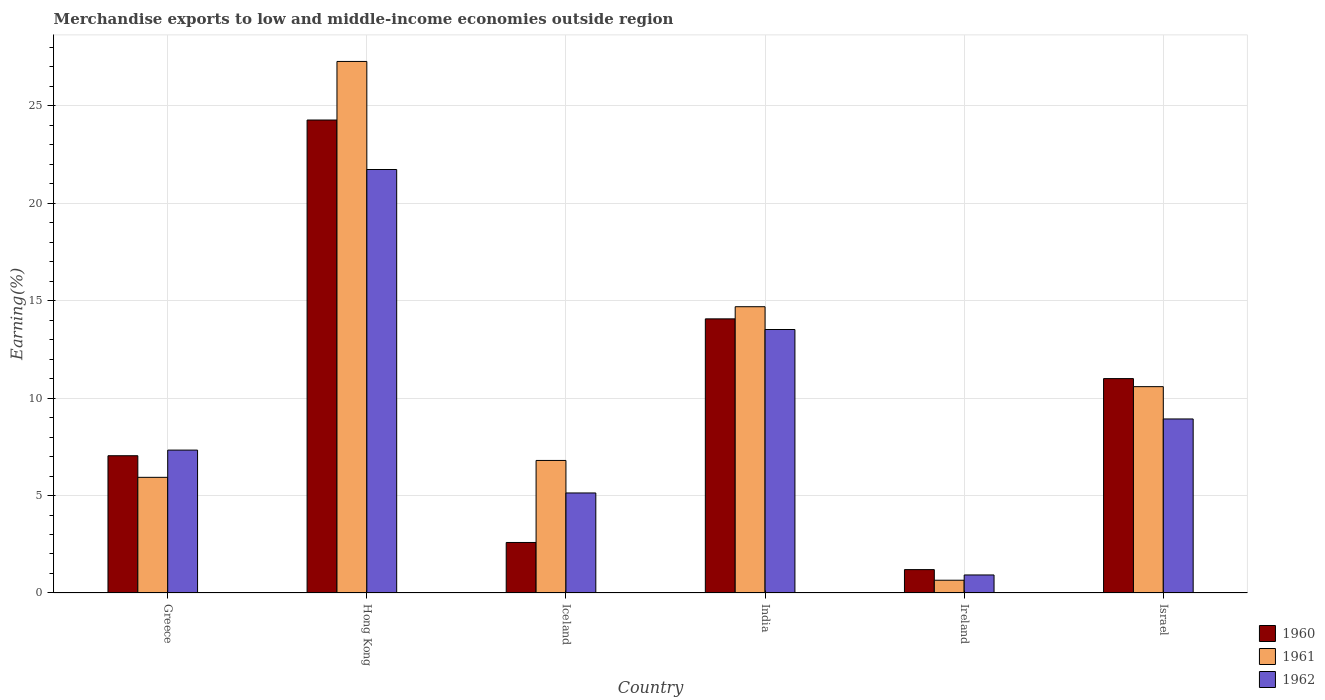How many different coloured bars are there?
Keep it short and to the point. 3. How many groups of bars are there?
Make the answer very short. 6. How many bars are there on the 4th tick from the left?
Offer a terse response. 3. How many bars are there on the 6th tick from the right?
Your response must be concise. 3. What is the percentage of amount earned from merchandise exports in 1962 in Hong Kong?
Keep it short and to the point. 21.72. Across all countries, what is the maximum percentage of amount earned from merchandise exports in 1962?
Make the answer very short. 21.72. Across all countries, what is the minimum percentage of amount earned from merchandise exports in 1960?
Give a very brief answer. 1.2. In which country was the percentage of amount earned from merchandise exports in 1960 maximum?
Offer a terse response. Hong Kong. In which country was the percentage of amount earned from merchandise exports in 1962 minimum?
Keep it short and to the point. Ireland. What is the total percentage of amount earned from merchandise exports in 1962 in the graph?
Provide a short and direct response. 57.55. What is the difference between the percentage of amount earned from merchandise exports in 1960 in Hong Kong and that in Ireland?
Keep it short and to the point. 23.06. What is the difference between the percentage of amount earned from merchandise exports in 1961 in India and the percentage of amount earned from merchandise exports in 1960 in Hong Kong?
Provide a short and direct response. -9.58. What is the average percentage of amount earned from merchandise exports in 1961 per country?
Make the answer very short. 10.99. What is the difference between the percentage of amount earned from merchandise exports of/in 1961 and percentage of amount earned from merchandise exports of/in 1962 in India?
Your answer should be compact. 1.17. What is the ratio of the percentage of amount earned from merchandise exports in 1962 in Greece to that in India?
Make the answer very short. 0.54. Is the difference between the percentage of amount earned from merchandise exports in 1961 in Ireland and Israel greater than the difference between the percentage of amount earned from merchandise exports in 1962 in Ireland and Israel?
Your answer should be compact. No. What is the difference between the highest and the second highest percentage of amount earned from merchandise exports in 1961?
Your answer should be compact. -16.68. What is the difference between the highest and the lowest percentage of amount earned from merchandise exports in 1961?
Your response must be concise. 26.61. What does the 2nd bar from the right in Greece represents?
Give a very brief answer. 1961. Are the values on the major ticks of Y-axis written in scientific E-notation?
Make the answer very short. No. Does the graph contain any zero values?
Make the answer very short. No. Does the graph contain grids?
Offer a terse response. Yes. How are the legend labels stacked?
Ensure brevity in your answer.  Vertical. What is the title of the graph?
Offer a terse response. Merchandise exports to low and middle-income economies outside region. Does "1963" appear as one of the legend labels in the graph?
Provide a short and direct response. No. What is the label or title of the X-axis?
Your response must be concise. Country. What is the label or title of the Y-axis?
Offer a terse response. Earning(%). What is the Earning(%) of 1960 in Greece?
Give a very brief answer. 7.04. What is the Earning(%) of 1961 in Greece?
Offer a terse response. 5.93. What is the Earning(%) of 1962 in Greece?
Keep it short and to the point. 7.33. What is the Earning(%) of 1960 in Hong Kong?
Give a very brief answer. 24.26. What is the Earning(%) of 1961 in Hong Kong?
Offer a terse response. 27.27. What is the Earning(%) of 1962 in Hong Kong?
Your answer should be very brief. 21.72. What is the Earning(%) of 1960 in Iceland?
Make the answer very short. 2.59. What is the Earning(%) in 1961 in Iceland?
Provide a short and direct response. 6.8. What is the Earning(%) of 1962 in Iceland?
Provide a short and direct response. 5.13. What is the Earning(%) in 1960 in India?
Offer a terse response. 14.06. What is the Earning(%) in 1961 in India?
Keep it short and to the point. 14.68. What is the Earning(%) in 1962 in India?
Offer a very short reply. 13.52. What is the Earning(%) in 1960 in Ireland?
Your answer should be compact. 1.2. What is the Earning(%) in 1961 in Ireland?
Provide a short and direct response. 0.65. What is the Earning(%) of 1962 in Ireland?
Provide a short and direct response. 0.92. What is the Earning(%) in 1960 in Israel?
Your response must be concise. 11. What is the Earning(%) in 1961 in Israel?
Your response must be concise. 10.58. What is the Earning(%) of 1962 in Israel?
Your response must be concise. 8.93. Across all countries, what is the maximum Earning(%) in 1960?
Your response must be concise. 24.26. Across all countries, what is the maximum Earning(%) of 1961?
Your response must be concise. 27.27. Across all countries, what is the maximum Earning(%) of 1962?
Give a very brief answer. 21.72. Across all countries, what is the minimum Earning(%) in 1960?
Provide a succinct answer. 1.2. Across all countries, what is the minimum Earning(%) of 1961?
Ensure brevity in your answer.  0.65. Across all countries, what is the minimum Earning(%) in 1962?
Your answer should be very brief. 0.92. What is the total Earning(%) in 1960 in the graph?
Your answer should be compact. 60.15. What is the total Earning(%) in 1961 in the graph?
Provide a short and direct response. 65.92. What is the total Earning(%) of 1962 in the graph?
Make the answer very short. 57.55. What is the difference between the Earning(%) of 1960 in Greece and that in Hong Kong?
Keep it short and to the point. -17.22. What is the difference between the Earning(%) in 1961 in Greece and that in Hong Kong?
Your answer should be compact. -21.33. What is the difference between the Earning(%) of 1962 in Greece and that in Hong Kong?
Provide a short and direct response. -14.39. What is the difference between the Earning(%) of 1960 in Greece and that in Iceland?
Your answer should be very brief. 4.45. What is the difference between the Earning(%) of 1961 in Greece and that in Iceland?
Offer a terse response. -0.87. What is the difference between the Earning(%) in 1962 in Greece and that in Iceland?
Your answer should be very brief. 2.2. What is the difference between the Earning(%) in 1960 in Greece and that in India?
Ensure brevity in your answer.  -7.02. What is the difference between the Earning(%) in 1961 in Greece and that in India?
Provide a succinct answer. -8.75. What is the difference between the Earning(%) in 1962 in Greece and that in India?
Offer a very short reply. -6.19. What is the difference between the Earning(%) in 1960 in Greece and that in Ireland?
Make the answer very short. 5.84. What is the difference between the Earning(%) in 1961 in Greece and that in Ireland?
Offer a terse response. 5.28. What is the difference between the Earning(%) in 1962 in Greece and that in Ireland?
Your response must be concise. 6.41. What is the difference between the Earning(%) in 1960 in Greece and that in Israel?
Keep it short and to the point. -3.96. What is the difference between the Earning(%) of 1961 in Greece and that in Israel?
Give a very brief answer. -4.65. What is the difference between the Earning(%) in 1962 in Greece and that in Israel?
Your response must be concise. -1.6. What is the difference between the Earning(%) of 1960 in Hong Kong and that in Iceland?
Provide a succinct answer. 21.67. What is the difference between the Earning(%) in 1961 in Hong Kong and that in Iceland?
Give a very brief answer. 20.47. What is the difference between the Earning(%) in 1962 in Hong Kong and that in Iceland?
Give a very brief answer. 16.59. What is the difference between the Earning(%) in 1960 in Hong Kong and that in India?
Your response must be concise. 10.2. What is the difference between the Earning(%) of 1961 in Hong Kong and that in India?
Your answer should be compact. 12.58. What is the difference between the Earning(%) in 1962 in Hong Kong and that in India?
Keep it short and to the point. 8.21. What is the difference between the Earning(%) of 1960 in Hong Kong and that in Ireland?
Keep it short and to the point. 23.06. What is the difference between the Earning(%) of 1961 in Hong Kong and that in Ireland?
Keep it short and to the point. 26.61. What is the difference between the Earning(%) of 1962 in Hong Kong and that in Ireland?
Offer a terse response. 20.8. What is the difference between the Earning(%) of 1960 in Hong Kong and that in Israel?
Offer a very short reply. 13.26. What is the difference between the Earning(%) of 1961 in Hong Kong and that in Israel?
Ensure brevity in your answer.  16.68. What is the difference between the Earning(%) in 1962 in Hong Kong and that in Israel?
Ensure brevity in your answer.  12.8. What is the difference between the Earning(%) in 1960 in Iceland and that in India?
Provide a short and direct response. -11.47. What is the difference between the Earning(%) of 1961 in Iceland and that in India?
Provide a succinct answer. -7.89. What is the difference between the Earning(%) of 1962 in Iceland and that in India?
Give a very brief answer. -8.38. What is the difference between the Earning(%) in 1960 in Iceland and that in Ireland?
Offer a very short reply. 1.39. What is the difference between the Earning(%) of 1961 in Iceland and that in Ireland?
Your response must be concise. 6.14. What is the difference between the Earning(%) in 1962 in Iceland and that in Ireland?
Keep it short and to the point. 4.21. What is the difference between the Earning(%) in 1960 in Iceland and that in Israel?
Keep it short and to the point. -8.41. What is the difference between the Earning(%) of 1961 in Iceland and that in Israel?
Make the answer very short. -3.79. What is the difference between the Earning(%) of 1962 in Iceland and that in Israel?
Offer a terse response. -3.8. What is the difference between the Earning(%) of 1960 in India and that in Ireland?
Give a very brief answer. 12.86. What is the difference between the Earning(%) in 1961 in India and that in Ireland?
Provide a succinct answer. 14.03. What is the difference between the Earning(%) in 1962 in India and that in Ireland?
Ensure brevity in your answer.  12.59. What is the difference between the Earning(%) in 1960 in India and that in Israel?
Your answer should be very brief. 3.06. What is the difference between the Earning(%) of 1961 in India and that in Israel?
Give a very brief answer. 4.1. What is the difference between the Earning(%) of 1962 in India and that in Israel?
Ensure brevity in your answer.  4.59. What is the difference between the Earning(%) of 1960 in Ireland and that in Israel?
Your answer should be very brief. -9.8. What is the difference between the Earning(%) in 1961 in Ireland and that in Israel?
Your response must be concise. -9.93. What is the difference between the Earning(%) in 1962 in Ireland and that in Israel?
Your answer should be compact. -8. What is the difference between the Earning(%) of 1960 in Greece and the Earning(%) of 1961 in Hong Kong?
Keep it short and to the point. -20.22. What is the difference between the Earning(%) of 1960 in Greece and the Earning(%) of 1962 in Hong Kong?
Make the answer very short. -14.68. What is the difference between the Earning(%) in 1961 in Greece and the Earning(%) in 1962 in Hong Kong?
Make the answer very short. -15.79. What is the difference between the Earning(%) in 1960 in Greece and the Earning(%) in 1961 in Iceland?
Your answer should be compact. 0.24. What is the difference between the Earning(%) in 1960 in Greece and the Earning(%) in 1962 in Iceland?
Offer a very short reply. 1.91. What is the difference between the Earning(%) in 1961 in Greece and the Earning(%) in 1962 in Iceland?
Give a very brief answer. 0.8. What is the difference between the Earning(%) of 1960 in Greece and the Earning(%) of 1961 in India?
Give a very brief answer. -7.64. What is the difference between the Earning(%) of 1960 in Greece and the Earning(%) of 1962 in India?
Make the answer very short. -6.47. What is the difference between the Earning(%) in 1961 in Greece and the Earning(%) in 1962 in India?
Offer a terse response. -7.58. What is the difference between the Earning(%) in 1960 in Greece and the Earning(%) in 1961 in Ireland?
Ensure brevity in your answer.  6.39. What is the difference between the Earning(%) of 1960 in Greece and the Earning(%) of 1962 in Ireland?
Ensure brevity in your answer.  6.12. What is the difference between the Earning(%) in 1961 in Greece and the Earning(%) in 1962 in Ireland?
Provide a short and direct response. 5.01. What is the difference between the Earning(%) in 1960 in Greece and the Earning(%) in 1961 in Israel?
Your answer should be compact. -3.54. What is the difference between the Earning(%) of 1960 in Greece and the Earning(%) of 1962 in Israel?
Keep it short and to the point. -1.89. What is the difference between the Earning(%) of 1961 in Greece and the Earning(%) of 1962 in Israel?
Your answer should be compact. -2.99. What is the difference between the Earning(%) of 1960 in Hong Kong and the Earning(%) of 1961 in Iceland?
Offer a terse response. 17.46. What is the difference between the Earning(%) in 1960 in Hong Kong and the Earning(%) in 1962 in Iceland?
Give a very brief answer. 19.13. What is the difference between the Earning(%) of 1961 in Hong Kong and the Earning(%) of 1962 in Iceland?
Make the answer very short. 22.13. What is the difference between the Earning(%) of 1960 in Hong Kong and the Earning(%) of 1961 in India?
Give a very brief answer. 9.58. What is the difference between the Earning(%) in 1960 in Hong Kong and the Earning(%) in 1962 in India?
Keep it short and to the point. 10.75. What is the difference between the Earning(%) of 1961 in Hong Kong and the Earning(%) of 1962 in India?
Give a very brief answer. 13.75. What is the difference between the Earning(%) in 1960 in Hong Kong and the Earning(%) in 1961 in Ireland?
Ensure brevity in your answer.  23.61. What is the difference between the Earning(%) of 1960 in Hong Kong and the Earning(%) of 1962 in Ireland?
Keep it short and to the point. 23.34. What is the difference between the Earning(%) in 1961 in Hong Kong and the Earning(%) in 1962 in Ireland?
Your answer should be very brief. 26.34. What is the difference between the Earning(%) of 1960 in Hong Kong and the Earning(%) of 1961 in Israel?
Your answer should be compact. 13.68. What is the difference between the Earning(%) of 1960 in Hong Kong and the Earning(%) of 1962 in Israel?
Your response must be concise. 15.33. What is the difference between the Earning(%) in 1961 in Hong Kong and the Earning(%) in 1962 in Israel?
Provide a short and direct response. 18.34. What is the difference between the Earning(%) in 1960 in Iceland and the Earning(%) in 1961 in India?
Your answer should be very brief. -12.09. What is the difference between the Earning(%) in 1960 in Iceland and the Earning(%) in 1962 in India?
Offer a very short reply. -10.92. What is the difference between the Earning(%) in 1961 in Iceland and the Earning(%) in 1962 in India?
Provide a short and direct response. -6.72. What is the difference between the Earning(%) of 1960 in Iceland and the Earning(%) of 1961 in Ireland?
Keep it short and to the point. 1.94. What is the difference between the Earning(%) of 1961 in Iceland and the Earning(%) of 1962 in Ireland?
Offer a very short reply. 5.87. What is the difference between the Earning(%) of 1960 in Iceland and the Earning(%) of 1961 in Israel?
Offer a terse response. -7.99. What is the difference between the Earning(%) of 1960 in Iceland and the Earning(%) of 1962 in Israel?
Your answer should be very brief. -6.34. What is the difference between the Earning(%) of 1961 in Iceland and the Earning(%) of 1962 in Israel?
Provide a succinct answer. -2.13. What is the difference between the Earning(%) of 1960 in India and the Earning(%) of 1961 in Ireland?
Your answer should be compact. 13.41. What is the difference between the Earning(%) in 1960 in India and the Earning(%) in 1962 in Ireland?
Your response must be concise. 13.14. What is the difference between the Earning(%) in 1961 in India and the Earning(%) in 1962 in Ireland?
Your answer should be compact. 13.76. What is the difference between the Earning(%) in 1960 in India and the Earning(%) in 1961 in Israel?
Ensure brevity in your answer.  3.48. What is the difference between the Earning(%) of 1960 in India and the Earning(%) of 1962 in Israel?
Your answer should be compact. 5.13. What is the difference between the Earning(%) of 1961 in India and the Earning(%) of 1962 in Israel?
Make the answer very short. 5.76. What is the difference between the Earning(%) of 1960 in Ireland and the Earning(%) of 1961 in Israel?
Provide a short and direct response. -9.39. What is the difference between the Earning(%) in 1960 in Ireland and the Earning(%) in 1962 in Israel?
Offer a very short reply. -7.73. What is the difference between the Earning(%) in 1961 in Ireland and the Earning(%) in 1962 in Israel?
Offer a very short reply. -8.27. What is the average Earning(%) of 1960 per country?
Your answer should be very brief. 10.03. What is the average Earning(%) in 1961 per country?
Ensure brevity in your answer.  10.99. What is the average Earning(%) in 1962 per country?
Your response must be concise. 9.59. What is the difference between the Earning(%) of 1960 and Earning(%) of 1961 in Greece?
Provide a short and direct response. 1.11. What is the difference between the Earning(%) in 1960 and Earning(%) in 1962 in Greece?
Provide a short and direct response. -0.29. What is the difference between the Earning(%) in 1961 and Earning(%) in 1962 in Greece?
Keep it short and to the point. -1.4. What is the difference between the Earning(%) in 1960 and Earning(%) in 1961 in Hong Kong?
Give a very brief answer. -3. What is the difference between the Earning(%) in 1960 and Earning(%) in 1962 in Hong Kong?
Keep it short and to the point. 2.54. What is the difference between the Earning(%) in 1961 and Earning(%) in 1962 in Hong Kong?
Offer a terse response. 5.54. What is the difference between the Earning(%) of 1960 and Earning(%) of 1961 in Iceland?
Your answer should be compact. -4.21. What is the difference between the Earning(%) in 1960 and Earning(%) in 1962 in Iceland?
Offer a very short reply. -2.54. What is the difference between the Earning(%) in 1961 and Earning(%) in 1962 in Iceland?
Make the answer very short. 1.67. What is the difference between the Earning(%) in 1960 and Earning(%) in 1961 in India?
Provide a succinct answer. -0.62. What is the difference between the Earning(%) in 1960 and Earning(%) in 1962 in India?
Provide a short and direct response. 0.55. What is the difference between the Earning(%) of 1961 and Earning(%) of 1962 in India?
Your answer should be compact. 1.17. What is the difference between the Earning(%) in 1960 and Earning(%) in 1961 in Ireland?
Provide a short and direct response. 0.54. What is the difference between the Earning(%) in 1960 and Earning(%) in 1962 in Ireland?
Provide a succinct answer. 0.27. What is the difference between the Earning(%) in 1961 and Earning(%) in 1962 in Ireland?
Keep it short and to the point. -0.27. What is the difference between the Earning(%) in 1960 and Earning(%) in 1961 in Israel?
Your answer should be compact. 0.41. What is the difference between the Earning(%) in 1960 and Earning(%) in 1962 in Israel?
Provide a short and direct response. 2.07. What is the difference between the Earning(%) in 1961 and Earning(%) in 1962 in Israel?
Provide a succinct answer. 1.66. What is the ratio of the Earning(%) in 1960 in Greece to that in Hong Kong?
Your answer should be very brief. 0.29. What is the ratio of the Earning(%) of 1961 in Greece to that in Hong Kong?
Offer a terse response. 0.22. What is the ratio of the Earning(%) in 1962 in Greece to that in Hong Kong?
Give a very brief answer. 0.34. What is the ratio of the Earning(%) in 1960 in Greece to that in Iceland?
Ensure brevity in your answer.  2.72. What is the ratio of the Earning(%) in 1961 in Greece to that in Iceland?
Provide a succinct answer. 0.87. What is the ratio of the Earning(%) of 1962 in Greece to that in Iceland?
Your answer should be very brief. 1.43. What is the ratio of the Earning(%) of 1960 in Greece to that in India?
Ensure brevity in your answer.  0.5. What is the ratio of the Earning(%) of 1961 in Greece to that in India?
Offer a very short reply. 0.4. What is the ratio of the Earning(%) in 1962 in Greece to that in India?
Your answer should be compact. 0.54. What is the ratio of the Earning(%) in 1960 in Greece to that in Ireland?
Ensure brevity in your answer.  5.87. What is the ratio of the Earning(%) in 1961 in Greece to that in Ireland?
Ensure brevity in your answer.  9.06. What is the ratio of the Earning(%) of 1962 in Greece to that in Ireland?
Make the answer very short. 7.93. What is the ratio of the Earning(%) in 1960 in Greece to that in Israel?
Your answer should be very brief. 0.64. What is the ratio of the Earning(%) in 1961 in Greece to that in Israel?
Offer a very short reply. 0.56. What is the ratio of the Earning(%) in 1962 in Greece to that in Israel?
Your answer should be compact. 0.82. What is the ratio of the Earning(%) in 1960 in Hong Kong to that in Iceland?
Offer a very short reply. 9.36. What is the ratio of the Earning(%) in 1961 in Hong Kong to that in Iceland?
Your response must be concise. 4.01. What is the ratio of the Earning(%) in 1962 in Hong Kong to that in Iceland?
Your answer should be compact. 4.23. What is the ratio of the Earning(%) of 1960 in Hong Kong to that in India?
Your response must be concise. 1.73. What is the ratio of the Earning(%) of 1961 in Hong Kong to that in India?
Provide a short and direct response. 1.86. What is the ratio of the Earning(%) in 1962 in Hong Kong to that in India?
Provide a short and direct response. 1.61. What is the ratio of the Earning(%) in 1960 in Hong Kong to that in Ireland?
Provide a succinct answer. 20.23. What is the ratio of the Earning(%) of 1961 in Hong Kong to that in Ireland?
Offer a terse response. 41.66. What is the ratio of the Earning(%) in 1962 in Hong Kong to that in Ireland?
Your answer should be compact. 23.49. What is the ratio of the Earning(%) of 1960 in Hong Kong to that in Israel?
Ensure brevity in your answer.  2.21. What is the ratio of the Earning(%) of 1961 in Hong Kong to that in Israel?
Your answer should be very brief. 2.58. What is the ratio of the Earning(%) in 1962 in Hong Kong to that in Israel?
Provide a short and direct response. 2.43. What is the ratio of the Earning(%) in 1960 in Iceland to that in India?
Your answer should be compact. 0.18. What is the ratio of the Earning(%) of 1961 in Iceland to that in India?
Make the answer very short. 0.46. What is the ratio of the Earning(%) in 1962 in Iceland to that in India?
Your answer should be compact. 0.38. What is the ratio of the Earning(%) in 1960 in Iceland to that in Ireland?
Your response must be concise. 2.16. What is the ratio of the Earning(%) of 1961 in Iceland to that in Ireland?
Provide a succinct answer. 10.39. What is the ratio of the Earning(%) of 1962 in Iceland to that in Ireland?
Provide a short and direct response. 5.55. What is the ratio of the Earning(%) in 1960 in Iceland to that in Israel?
Your response must be concise. 0.24. What is the ratio of the Earning(%) of 1961 in Iceland to that in Israel?
Provide a short and direct response. 0.64. What is the ratio of the Earning(%) of 1962 in Iceland to that in Israel?
Provide a short and direct response. 0.57. What is the ratio of the Earning(%) in 1960 in India to that in Ireland?
Provide a succinct answer. 11.73. What is the ratio of the Earning(%) of 1961 in India to that in Ireland?
Your answer should be very brief. 22.44. What is the ratio of the Earning(%) of 1962 in India to that in Ireland?
Your answer should be very brief. 14.61. What is the ratio of the Earning(%) in 1960 in India to that in Israel?
Offer a very short reply. 1.28. What is the ratio of the Earning(%) in 1961 in India to that in Israel?
Offer a terse response. 1.39. What is the ratio of the Earning(%) in 1962 in India to that in Israel?
Offer a terse response. 1.51. What is the ratio of the Earning(%) of 1960 in Ireland to that in Israel?
Your answer should be compact. 0.11. What is the ratio of the Earning(%) of 1961 in Ireland to that in Israel?
Keep it short and to the point. 0.06. What is the ratio of the Earning(%) in 1962 in Ireland to that in Israel?
Offer a terse response. 0.1. What is the difference between the highest and the second highest Earning(%) of 1960?
Ensure brevity in your answer.  10.2. What is the difference between the highest and the second highest Earning(%) of 1961?
Provide a short and direct response. 12.58. What is the difference between the highest and the second highest Earning(%) in 1962?
Your answer should be compact. 8.21. What is the difference between the highest and the lowest Earning(%) of 1960?
Make the answer very short. 23.06. What is the difference between the highest and the lowest Earning(%) in 1961?
Make the answer very short. 26.61. What is the difference between the highest and the lowest Earning(%) of 1962?
Your response must be concise. 20.8. 